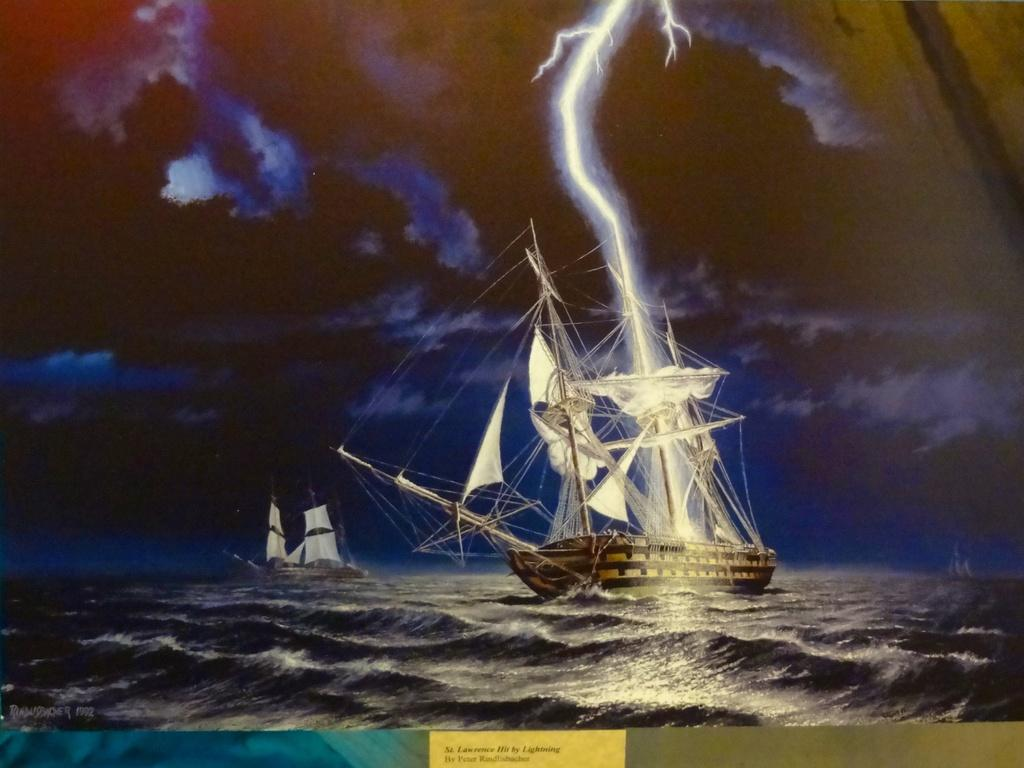What type of artwork is shown in the image? The image appears to be a painting. What is the main subject of the painting? The painting depicts ships sailing on the water. How would you describe the sky in the painting? The sky in the painting is dark. What weather phenomena can be seen in the sky of the painting? There is lightning and thunder in the sky of the painting. What type of cork can be seen floating on the water in the painting? There is no cork present in the painting; it depicts ships sailing on the water. What type of cracker is being eaten by the people on the ships in the painting? There are no people or crackers depicted in the painting; it only shows ships sailing on the water. 